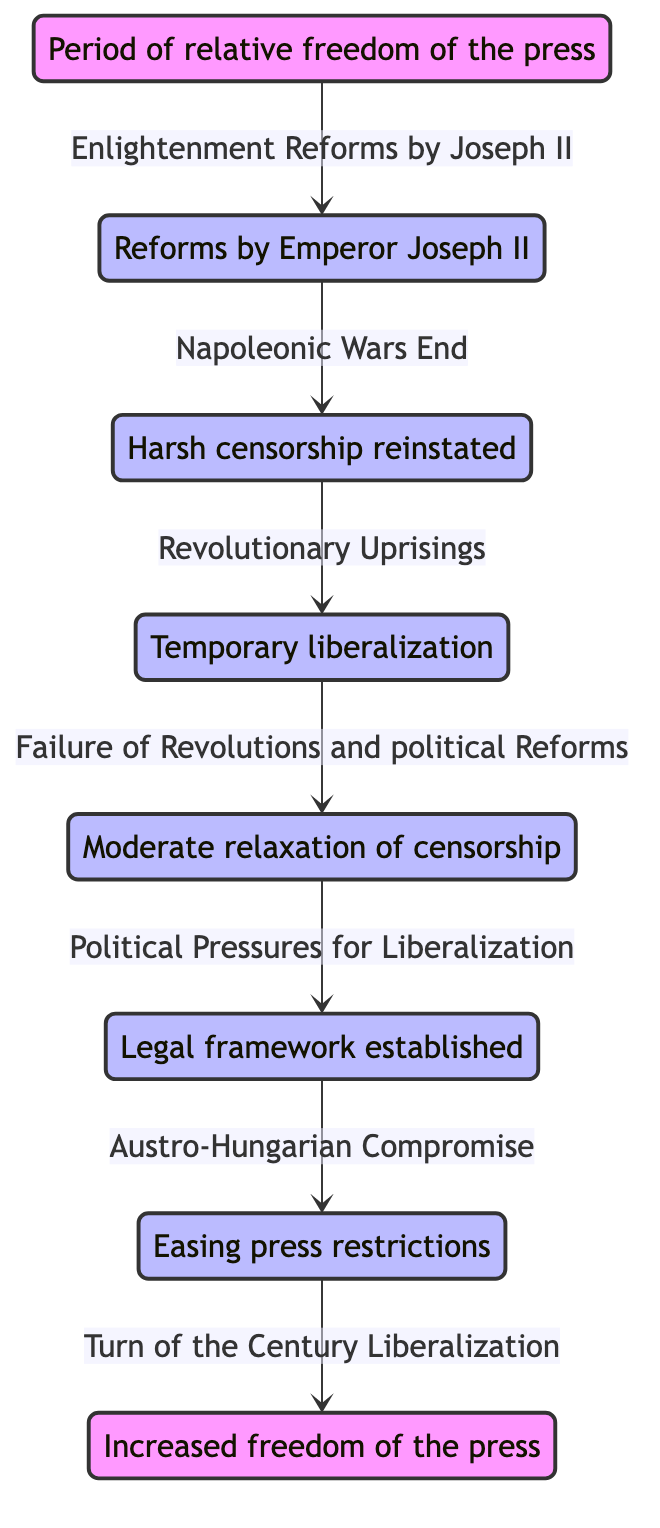What is the initial state of the diagram? The diagram begins with the state labeled "Initial Freedom of Press (1780)", indicating a time of relative freedom influenced by Enlightenment ideas.
Answer: Initial Freedom of Press (1780) How many states are represented in the diagram? By counting each state node, there are a total of eight listed states representing different periods of censorship in Austria.
Answer: 8 What is the transition condition from "Josephine Censorship (1780-1790)" to "Metternich Era Start (1810)"? The condition stated for this transition is "Napoleonic Wars End," which signifies the reason for this change in censorship laws.
Answer: Napoleonic Wars End Which state represents the period of temporary liberalization during revolutionary uprisings? The state that corresponds to temporary liberalization during the revolutions is labeled "Revolution of 1848."
Answer: Revolution of 1848 What is the final state of the diagram? The last node in the flow of the diagram is "Fin de Siècle Liberalization (1900)," indicating the end of the timeline represented.
Answer: Fin de Siècle Liberalization (1900) What were the main reforms leading to the "Press Law of 1862"? The transition to this state was primarily influenced by "Political Pressures for Liberalization," indicating a push for more freedoms in the press.
Answer: Political Pressures for Liberalization How does the "Compromise of 1867" relate to the timeline's progress? The "Compromise of 1867" follows the "Press Law of 1862" and indicates significant easing of press restrictions, reflecting political changes in the Austro-Hungarian Empire.
Answer: Easing press restrictions What is the relationship between the "Metternich Era Start (1810)" and the "Revolution of 1848"? The transition from the "Metternich Era Start (1810)" to "Revolution of 1848" occurs as a response to "Revolutionary Uprisings," which signifies public discontent and unrest.
Answer: Revolutionary Uprisings 